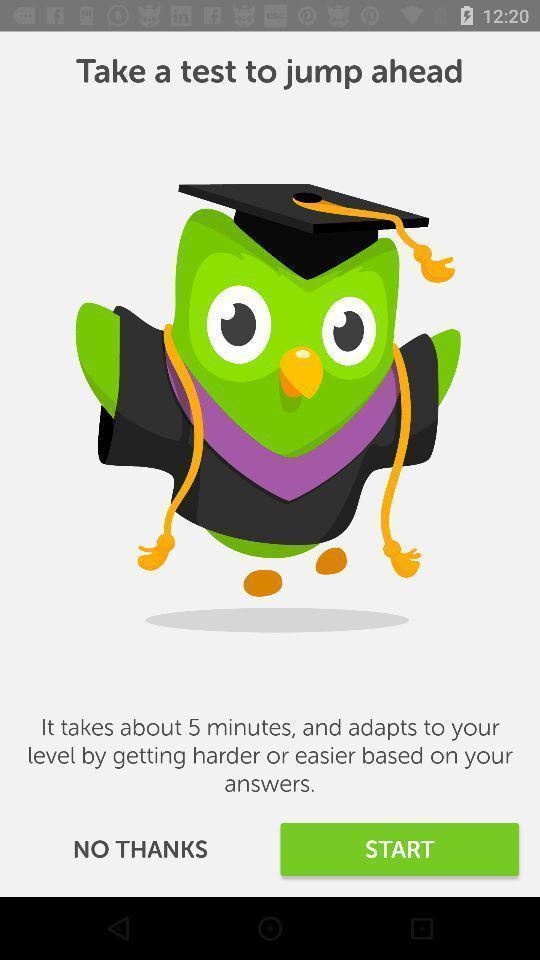Describe the visual elements of this screenshot. Page with start option in an learning application. 